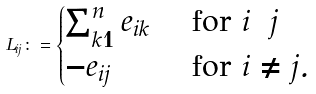Convert formula to latex. <formula><loc_0><loc_0><loc_500><loc_500>L _ { i j } \colon = \begin{cases} \sum _ { k = 1 } ^ { n } e _ { i k } & \text { for } i = j \\ - e _ { i j } & \text { for } i \neq j . \end{cases}</formula> 